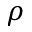Convert formula to latex. <formula><loc_0><loc_0><loc_500><loc_500>\rho</formula> 